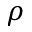Convert formula to latex. <formula><loc_0><loc_0><loc_500><loc_500>\rho</formula> 